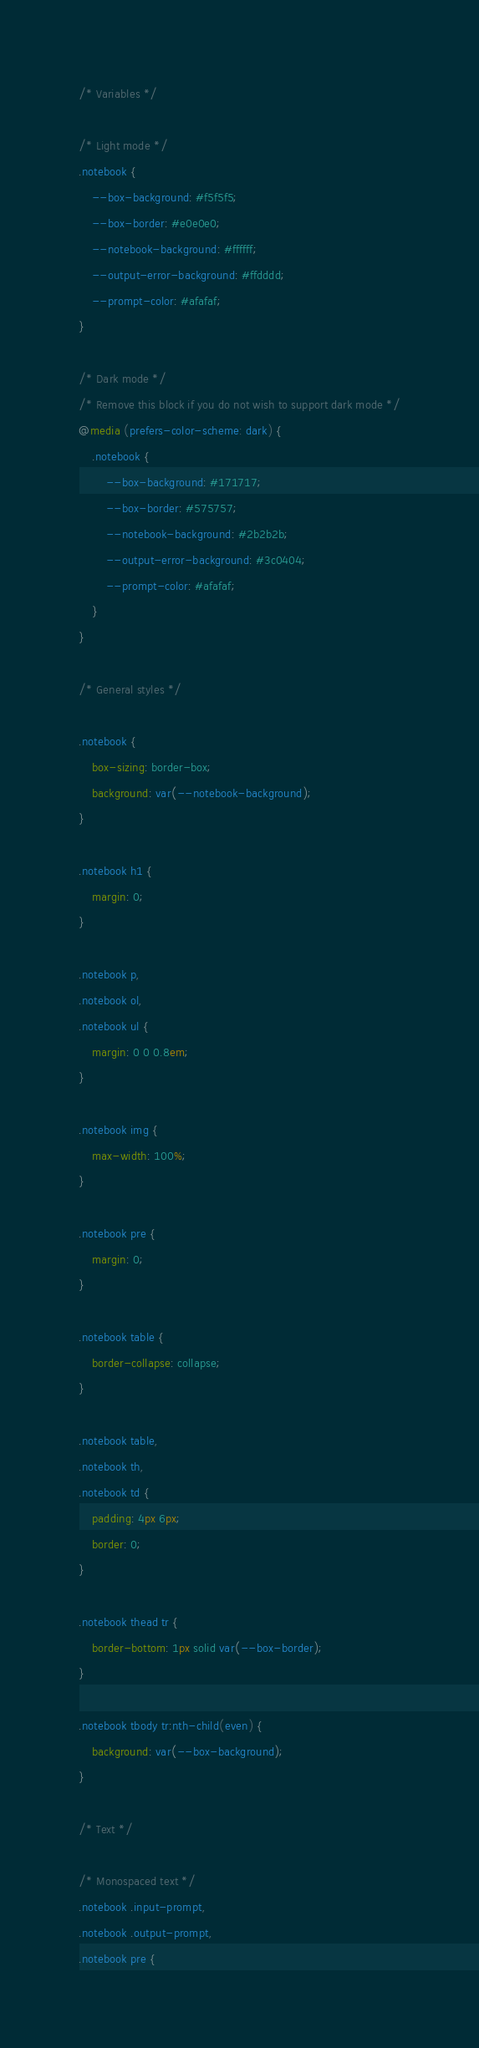<code> <loc_0><loc_0><loc_500><loc_500><_CSS_>/* Variables */

/* Light mode */
.notebook {
	--box-background: #f5f5f5;
	--box-border: #e0e0e0;
	--notebook-background: #ffffff;
	--output-error-background: #ffdddd;
	--prompt-color: #afafaf;
}

/* Dark mode */
/* Remove this block if you do not wish to support dark mode */
@media (prefers-color-scheme: dark) {
	.notebook {
		--box-background: #171717;
		--box-border: #575757;
		--notebook-background: #2b2b2b;
		--output-error-background: #3c0404;
		--prompt-color: #afafaf;
	}
}

/* General styles */

.notebook {
	box-sizing: border-box;
	background: var(--notebook-background);
}

.notebook h1 {
	margin: 0;
}

.notebook p,
.notebook ol,
.notebook ul {
	margin: 0 0 0.8em;
}

.notebook img {
	max-width: 100%;
}

.notebook pre {
	margin: 0;
}

.notebook table {
	border-collapse: collapse;
}

.notebook table,
.notebook th,
.notebook td {
	padding: 4px 6px;
	border: 0;
}

.notebook thead tr {
	border-bottom: 1px solid var(--box-border);
}

.notebook tbody tr:nth-child(even) {
	background: var(--box-background);
}

/* Text */

/* Monospaced text */
.notebook .input-prompt,
.notebook .output-prompt,
.notebook pre {</code> 